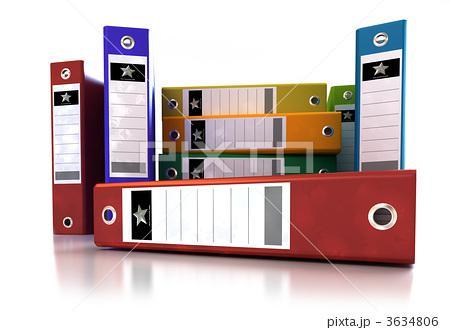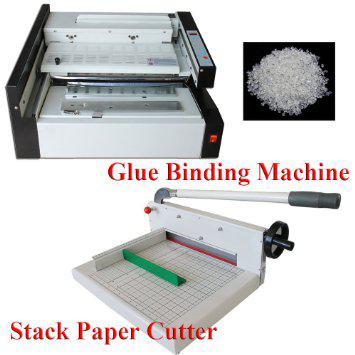The first image is the image on the left, the second image is the image on the right. For the images shown, is this caption "Both of the images show binders full of papers." true? Answer yes or no. No. 